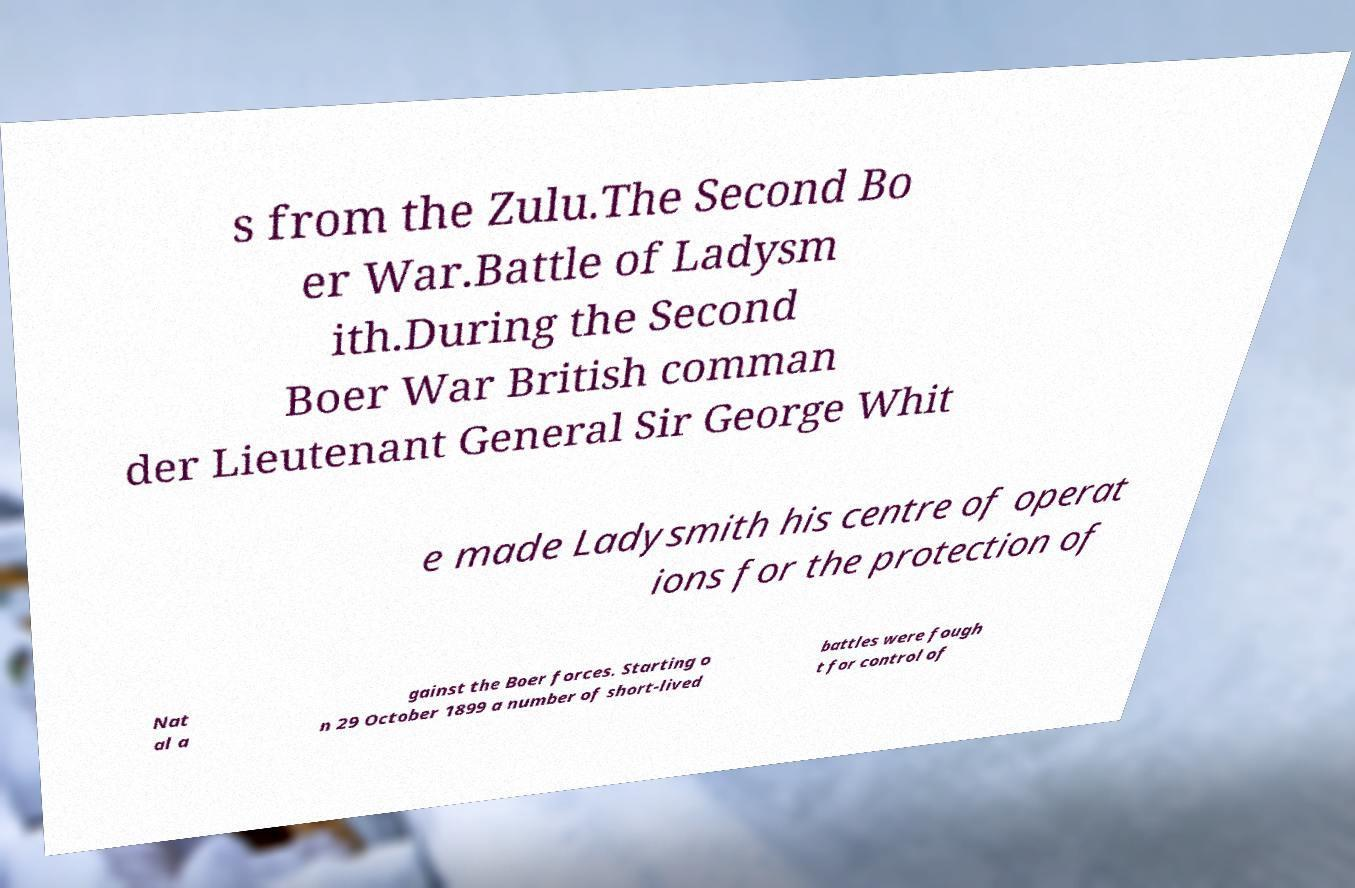Could you extract and type out the text from this image? s from the Zulu.The Second Bo er War.Battle of Ladysm ith.During the Second Boer War British comman der Lieutenant General Sir George Whit e made Ladysmith his centre of operat ions for the protection of Nat al a gainst the Boer forces. Starting o n 29 October 1899 a number of short-lived battles were fough t for control of 